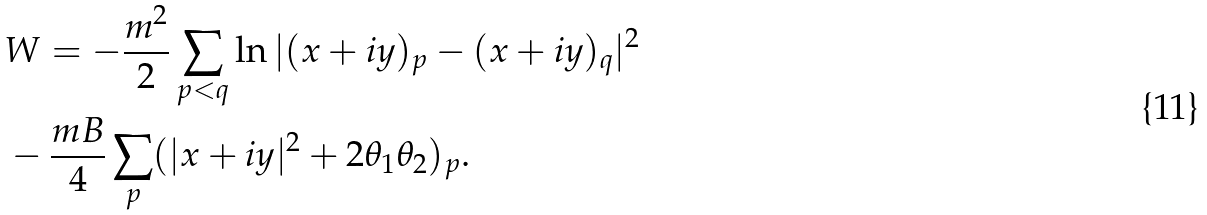Convert formula to latex. <formula><loc_0><loc_0><loc_500><loc_500>& W = - \frac { m ^ { 2 } } { 2 } \sum _ { p < q } \ln | ( x + i y ) _ { p } - ( x + i y ) _ { q } | ^ { 2 } \\ & - \frac { m B } { 4 } \sum _ { p } ( | x + i y | ^ { 2 } + 2 \theta _ { 1 } \theta _ { 2 } ) _ { p } .</formula> 